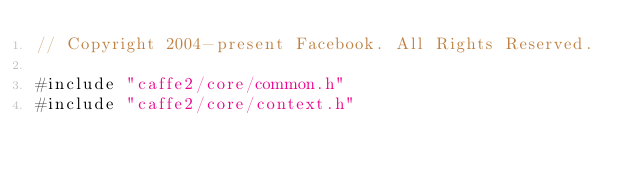<code> <loc_0><loc_0><loc_500><loc_500><_ObjectiveC_>// Copyright 2004-present Facebook. All Rights Reserved.

#include "caffe2/core/common.h"
#include "caffe2/core/context.h"
</code> 